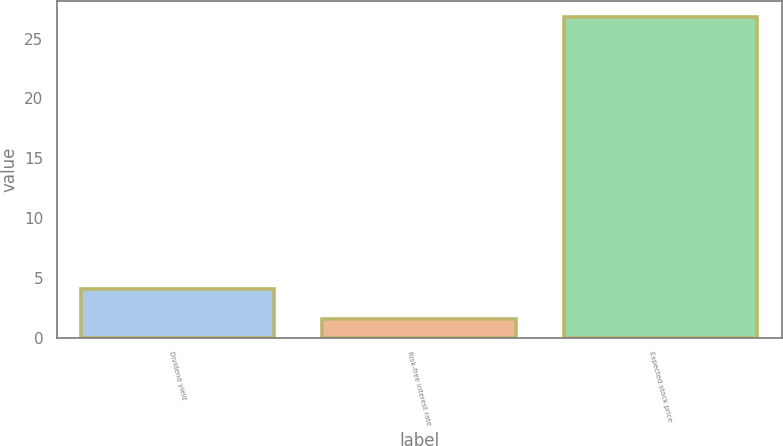<chart> <loc_0><loc_0><loc_500><loc_500><bar_chart><fcel>Dividend yield<fcel>Risk-free interest rate<fcel>Expected stock price<nl><fcel>4.09<fcel>1.57<fcel>26.76<nl></chart> 